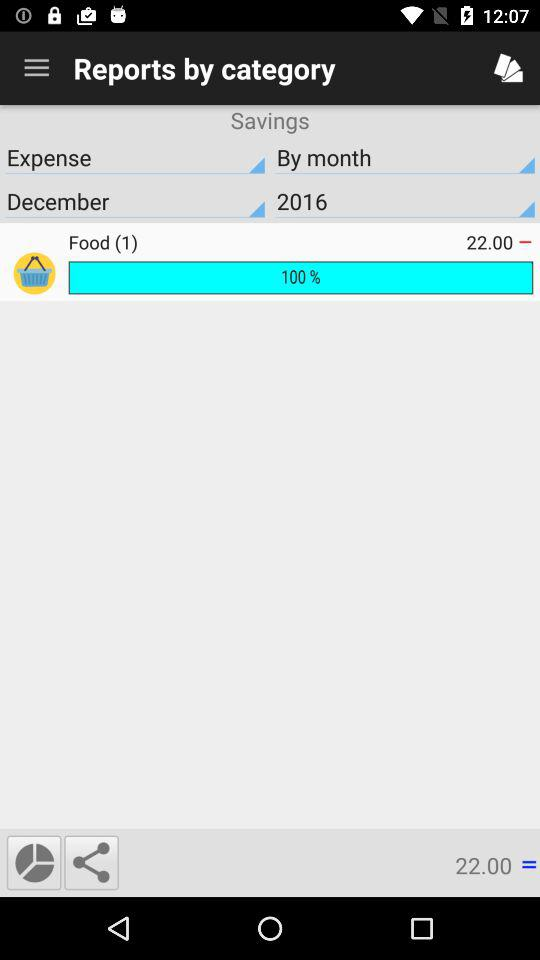What is the total price of food? The total price of the food is 22.00. 